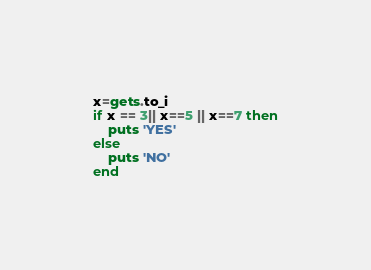Convert code to text. <code><loc_0><loc_0><loc_500><loc_500><_Ruby_>x=gets.to_i
if x == 3|| x==5 || x==7 then
	puts 'YES'
else
	puts 'NO'
end</code> 